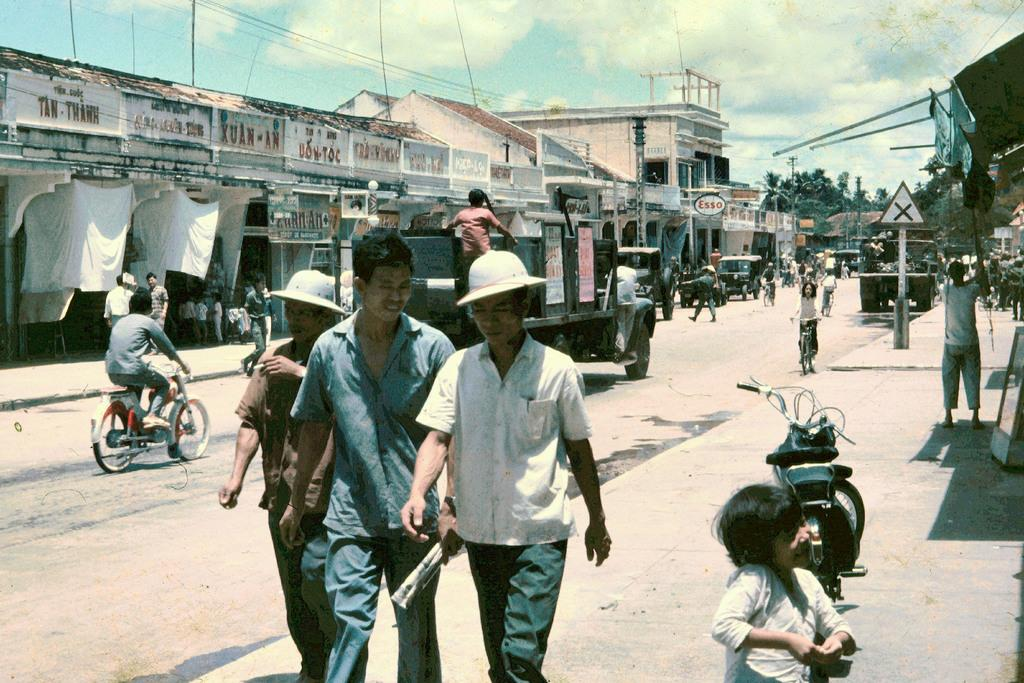How many people can be seen walking in the image? There are three people walking in the image. What surface are the people walking on? They are walking on a road. What else is moving in the image besides the people? There is a truck moving in the image. What type of area is depicted in the image? The scene appears to be a street area. What can be seen on the left side of the image? There are buildings on the left side of the image. What type of beam is holding up the airport in the image? There is no airport present in the image, and therefore no beam holding it up. 